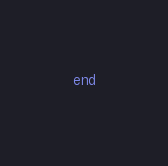Convert code to text. <code><loc_0><loc_0><loc_500><loc_500><_Ruby_>end
</code> 